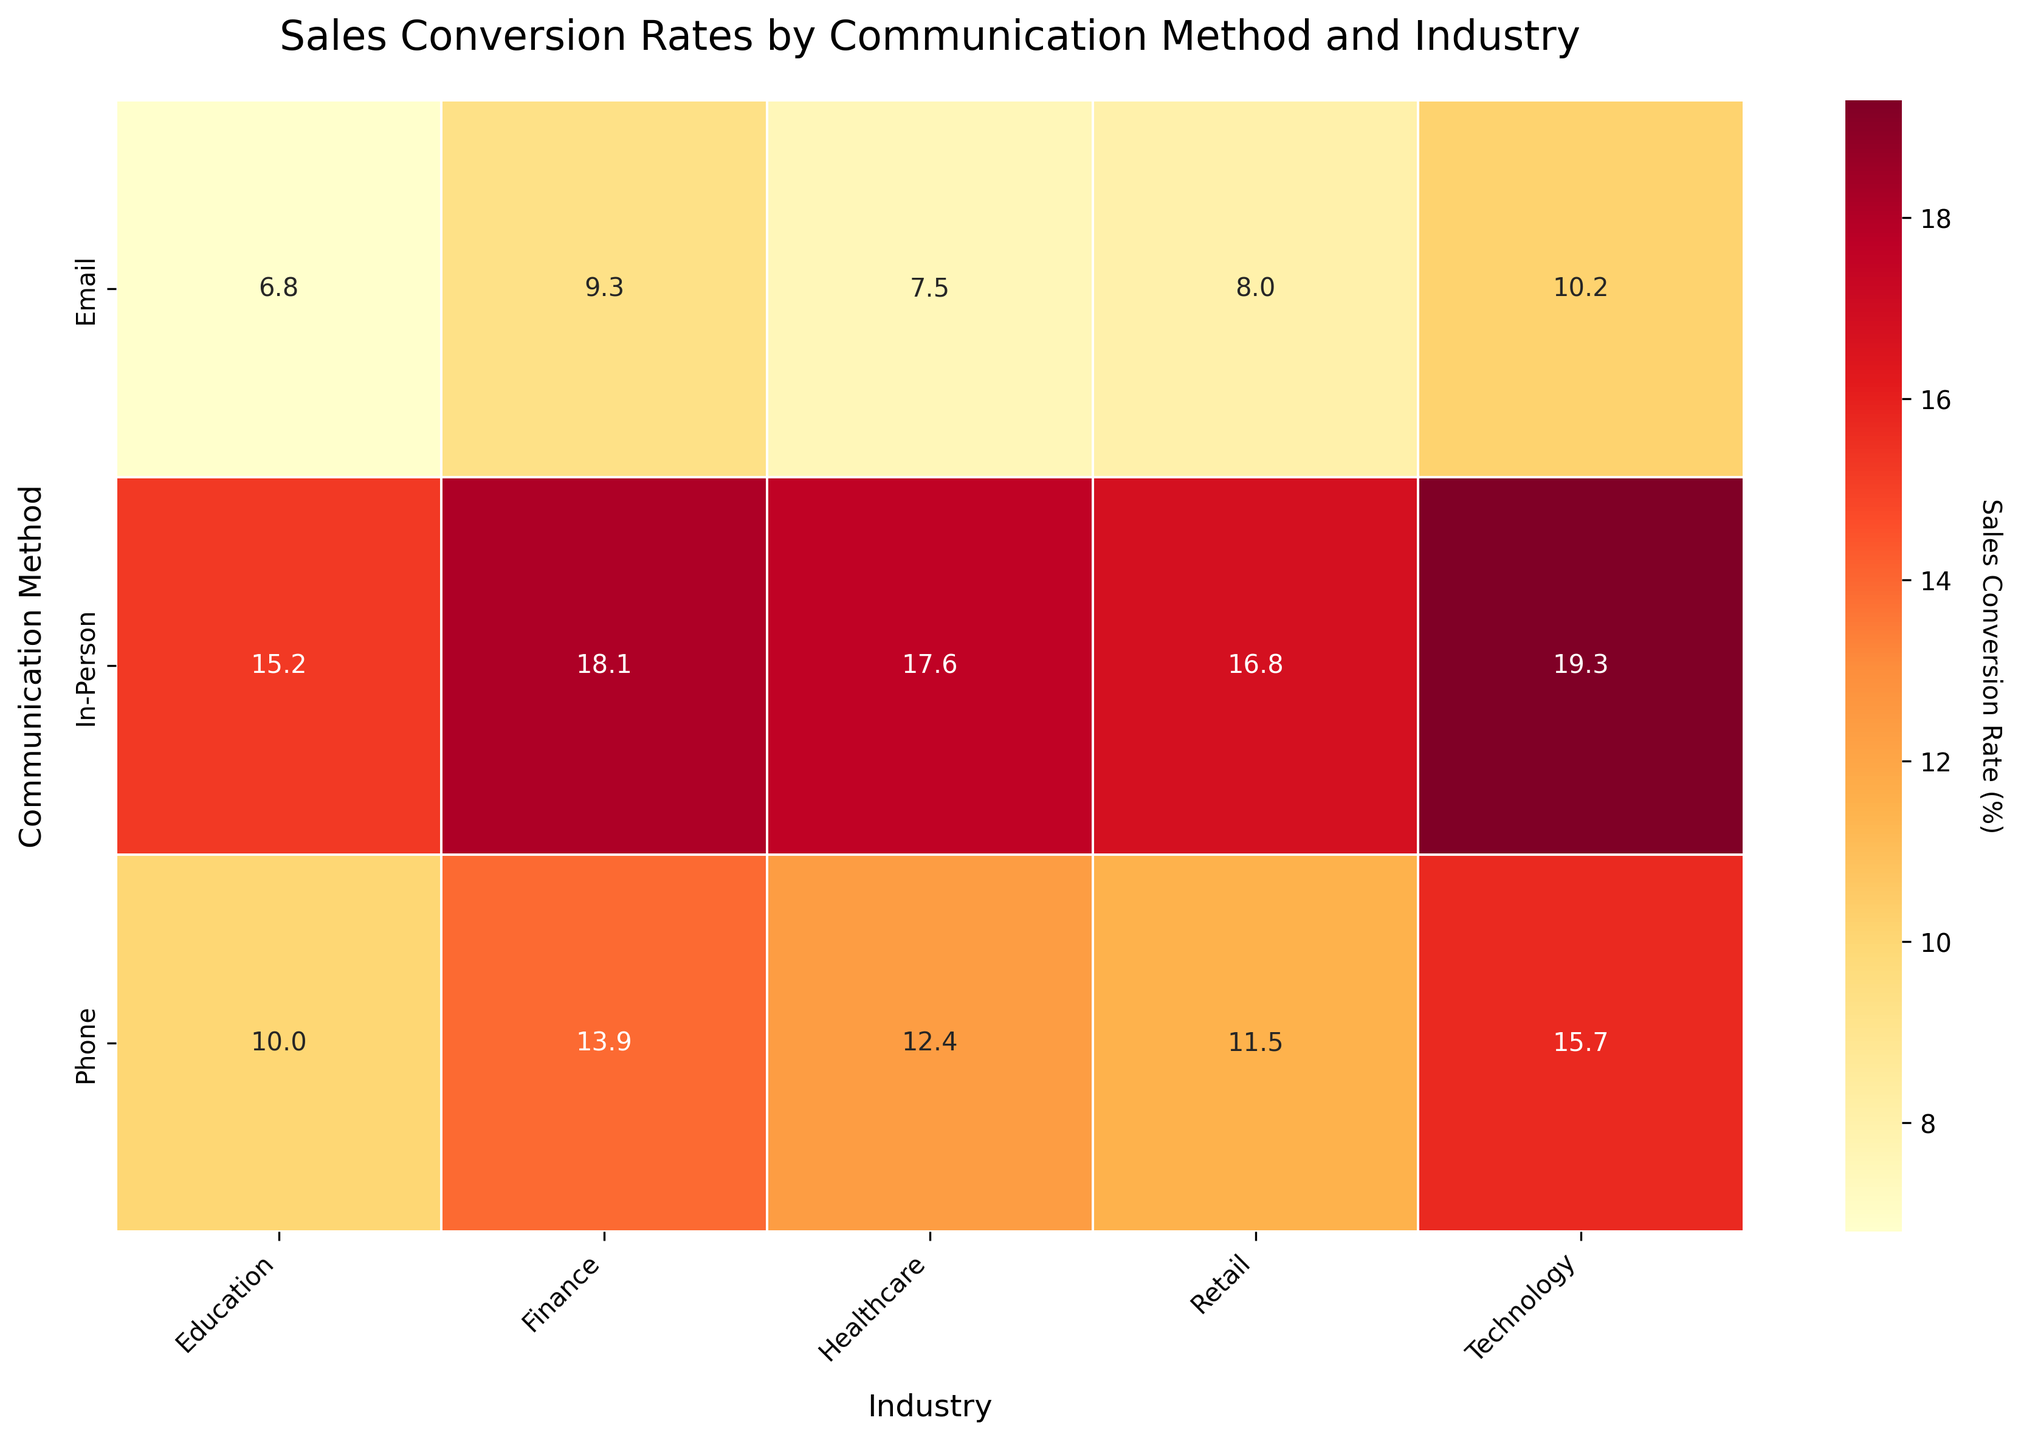What is the title of the figure? The figure title is located at the top of the plot and helps to identify the content of the visualization. It reads "Sales Conversion Rates by Communication Method and Industry".
Answer: Sales Conversion Rates by Communication Method and Industry Which communication method has the highest sales conversion rate in the Healthcare industry? To find the highest sales conversion rate for the Healthcare industry, locate the "Healthcare" column and compare the values for each communication method. The highest rate appears in the "In-Person" row with a value of 17.6%.
Answer: In-Person Which industry has the lowest conversion rate when using emails? Look at the "Email" row and find the lowest value across all industries. The lowest conversion rate is in the Education industry, with a rate of 6.8%.
Answer: Education What is the average sales conversion rate for Phone communication across all industries? Identify the conversion rates for Phone communication in the Healthcare, Technology, Finance, Education, and Retail industries. These values are 12.4, 15.7, 13.9, 10.0, and 11.5 respectively. Calculate the average by summing these values and dividing by the number of industries: (12.4 + 15.7 + 13.9 + 10.0 + 11.5) / 5 = 12.7.
Answer: 12.7 In which industry does In-Person communication outperform Email communication by the largest margin? To determine the largest margin, subtract the email conversion rates from the in-person conversion rates for each industry. The differences are:
- Healthcare: 17.6 - 7.5 = 10.1
- Technology: 19.3 - 10.2 = 9.1
- Finance: 18.1 - 9.3 = 8.8
- Education: 15.2 - 6.8 = 8.4
- Retail: 16.8 - 8.0 = 8.8
The largest margin is in the Healthcare industry with a difference of 10.1%.
Answer: Healthcare Which industry consistently shows high conversion rates across all communication methods? High conversion rates are typically those above the midpoint of the color scale used. Technology shows high rates for Email (10.2), Phone (15.7), and In-Person (19.3). Therefore, Technology consistently has high conversion rates across all methods.
Answer: Technology Compare the conversion rate for Phone communication in Education to the conversion rates for Email communication in Finance and Retail. Which is higher? The Phone communication rate for Education is 10.0. The Email conversion rates for Finance and Retail are 9.3 and 8.0, respectively. Therefore, 10.0 is higher than both 9.3 and 8.0.
Answer: Phone communication in Education What is the stardard deviation of the In-Person communication rates? First, list the In-Person communication rates: 17.6, 19.3, 18.1, 15.2, 16.8. Next, calculate the mean: (17.6 + 19.3 + 18.1 + 15.2 + 16.8) / 5 = 17.4. Subtract the mean from each rate and square the result, sum these squared differences, then divide by the number of rates: 
- (17.6-17.4)^2 = 0.04
- (19.3-17.4)^2 = 3.61
- (18.1-17.4)^2 = 0.49
- (15.2-17.4)^2 = 4.84
- (16.8-17.4)^2 = 0.36
Sum = 9.34. Divide by 5 to get 1.868. Take the square root, resulting in approximately 1.37.
Answer: Approximately 1.37 